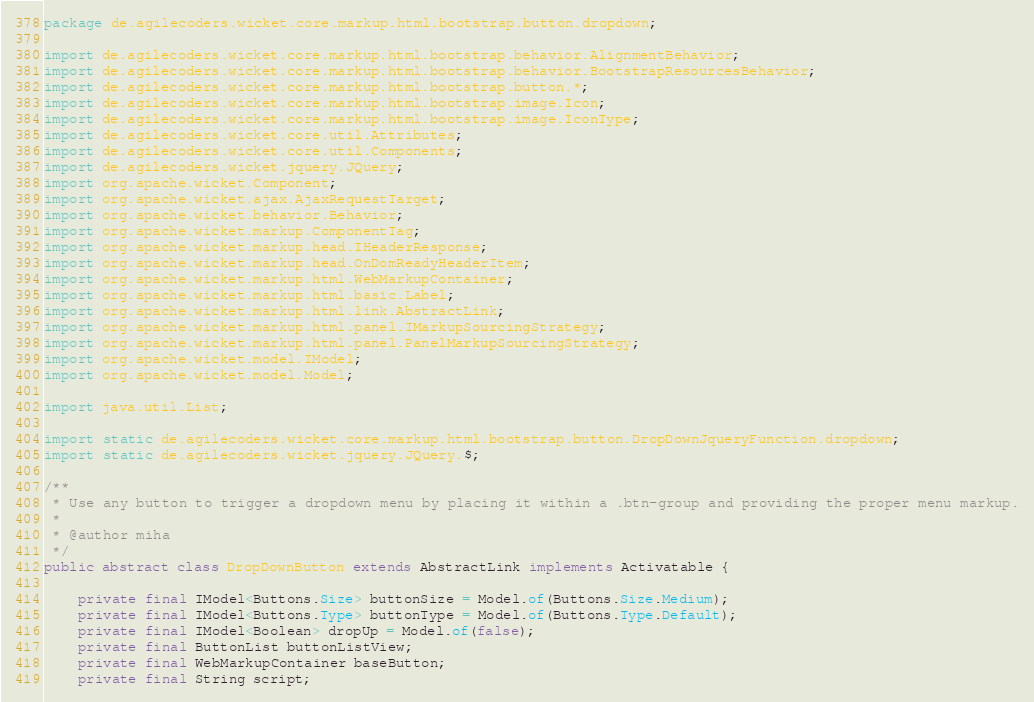<code> <loc_0><loc_0><loc_500><loc_500><_Java_>package de.agilecoders.wicket.core.markup.html.bootstrap.button.dropdown;

import de.agilecoders.wicket.core.markup.html.bootstrap.behavior.AlignmentBehavior;
import de.agilecoders.wicket.core.markup.html.bootstrap.behavior.BootstrapResourcesBehavior;
import de.agilecoders.wicket.core.markup.html.bootstrap.button.*;
import de.agilecoders.wicket.core.markup.html.bootstrap.image.Icon;
import de.agilecoders.wicket.core.markup.html.bootstrap.image.IconType;
import de.agilecoders.wicket.core.util.Attributes;
import de.agilecoders.wicket.core.util.Components;
import de.agilecoders.wicket.jquery.JQuery;
import org.apache.wicket.Component;
import org.apache.wicket.ajax.AjaxRequestTarget;
import org.apache.wicket.behavior.Behavior;
import org.apache.wicket.markup.ComponentTag;
import org.apache.wicket.markup.head.IHeaderResponse;
import org.apache.wicket.markup.head.OnDomReadyHeaderItem;
import org.apache.wicket.markup.html.WebMarkupContainer;
import org.apache.wicket.markup.html.basic.Label;
import org.apache.wicket.markup.html.link.AbstractLink;
import org.apache.wicket.markup.html.panel.IMarkupSourcingStrategy;
import org.apache.wicket.markup.html.panel.PanelMarkupSourcingStrategy;
import org.apache.wicket.model.IModel;
import org.apache.wicket.model.Model;

import java.util.List;

import static de.agilecoders.wicket.core.markup.html.bootstrap.button.DropDownJqueryFunction.dropdown;
import static de.agilecoders.wicket.jquery.JQuery.$;

/**
 * Use any button to trigger a dropdown menu by placing it within a .btn-group and providing the proper menu markup.
 *
 * @author miha
 */
public abstract class DropDownButton extends AbstractLink implements Activatable {

    private final IModel<Buttons.Size> buttonSize = Model.of(Buttons.Size.Medium);
    private final IModel<Buttons.Type> buttonType = Model.of(Buttons.Type.Default);
    private final IModel<Boolean> dropUp = Model.of(false);
    private final ButtonList buttonListView;
    private final WebMarkupContainer baseButton;
    private final String script;</code> 